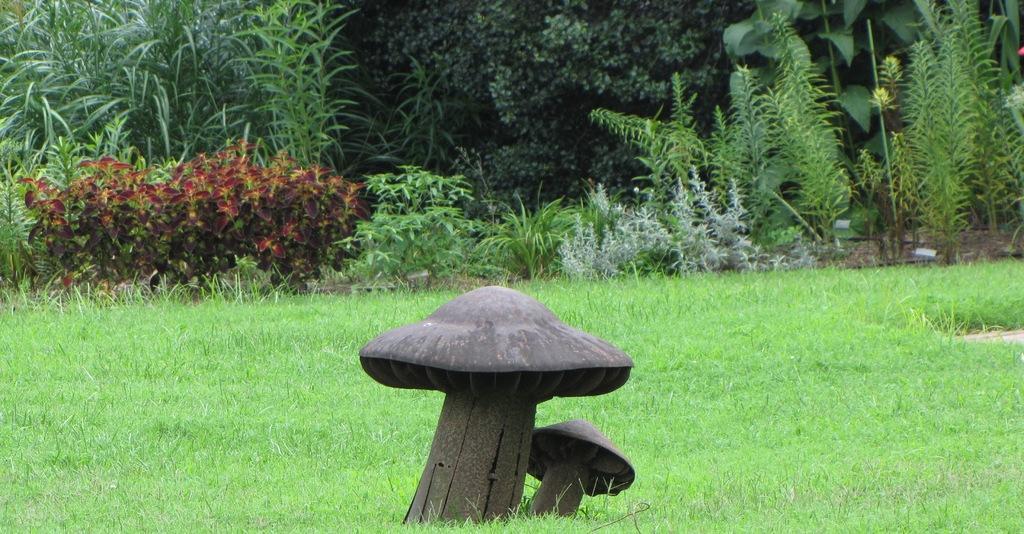Describe this image in one or two sentences. In this image we can see a statue. In the background, we can see group of plants and trees. 